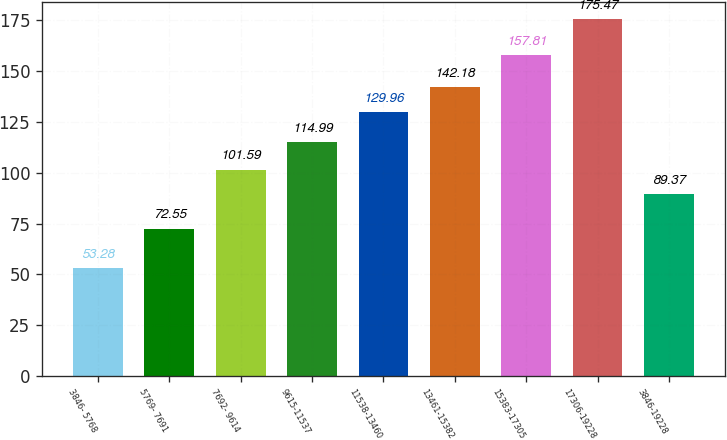Convert chart. <chart><loc_0><loc_0><loc_500><loc_500><bar_chart><fcel>3846- 5768<fcel>5769- 7691<fcel>7692- 9614<fcel>9615-11537<fcel>11538-13460<fcel>13461-15382<fcel>15383-17305<fcel>17306-19228<fcel>3846-19228<nl><fcel>53.28<fcel>72.55<fcel>101.59<fcel>114.99<fcel>129.96<fcel>142.18<fcel>157.81<fcel>175.47<fcel>89.37<nl></chart> 